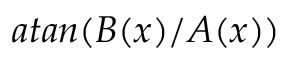Convert formula to latex. <formula><loc_0><loc_0><loc_500><loc_500>a t a n ( B ( x ) / A ( x ) )</formula> 